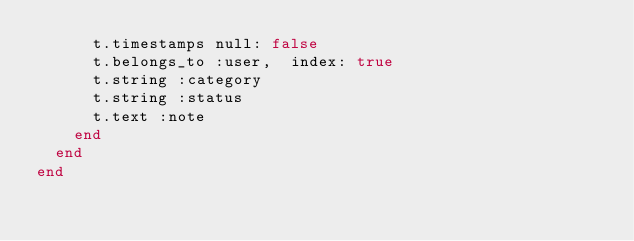Convert code to text. <code><loc_0><loc_0><loc_500><loc_500><_Ruby_>      t.timestamps null: false
      t.belongs_to :user,  index: true
      t.string :category
      t.string :status
      t.text :note
    end
  end
end
</code> 